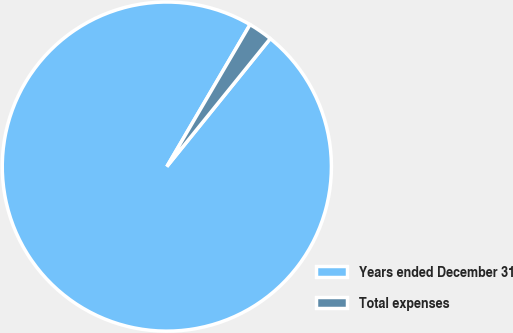Convert chart. <chart><loc_0><loc_0><loc_500><loc_500><pie_chart><fcel>Years ended December 31<fcel>Total expenses<nl><fcel>97.62%<fcel>2.38%<nl></chart> 